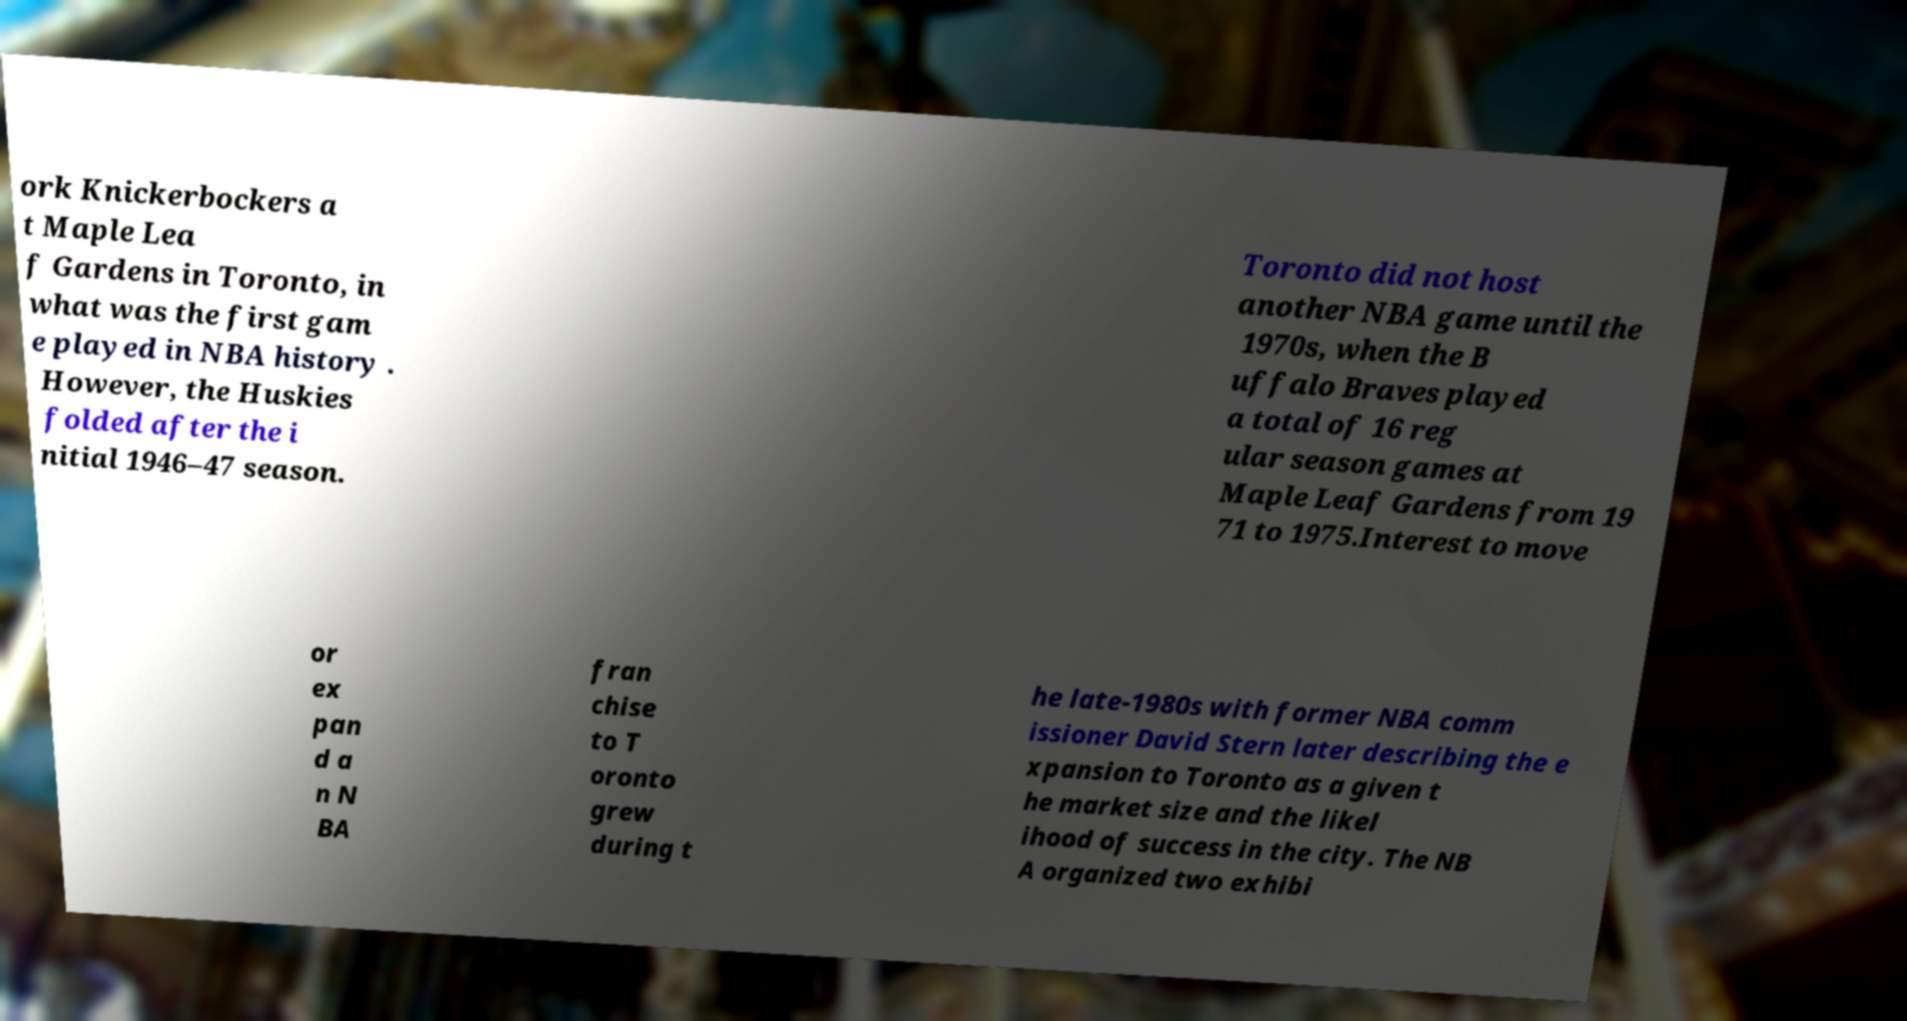For documentation purposes, I need the text within this image transcribed. Could you provide that? ork Knickerbockers a t Maple Lea f Gardens in Toronto, in what was the first gam e played in NBA history . However, the Huskies folded after the i nitial 1946–47 season. Toronto did not host another NBA game until the 1970s, when the B uffalo Braves played a total of 16 reg ular season games at Maple Leaf Gardens from 19 71 to 1975.Interest to move or ex pan d a n N BA fran chise to T oronto grew during t he late-1980s with former NBA comm issioner David Stern later describing the e xpansion to Toronto as a given t he market size and the likel ihood of success in the city. The NB A organized two exhibi 